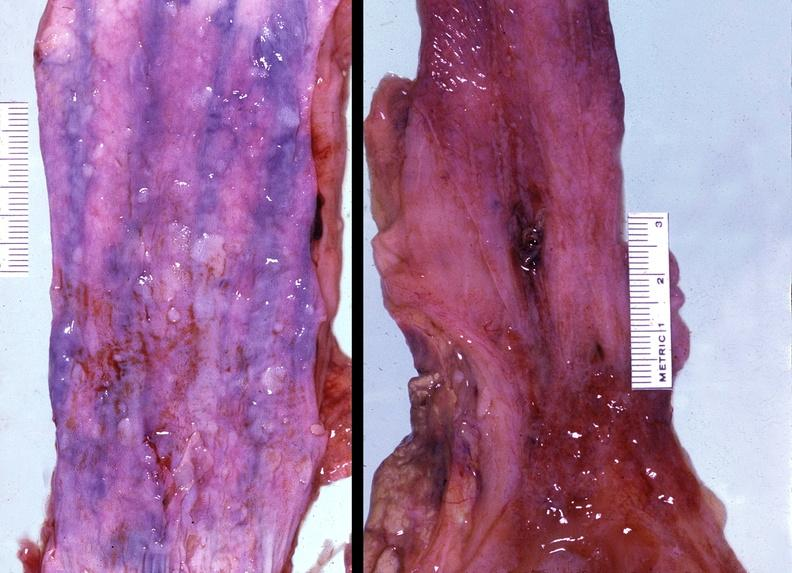what is present?
Answer the question using a single word or phrase. Gastrointestinal 